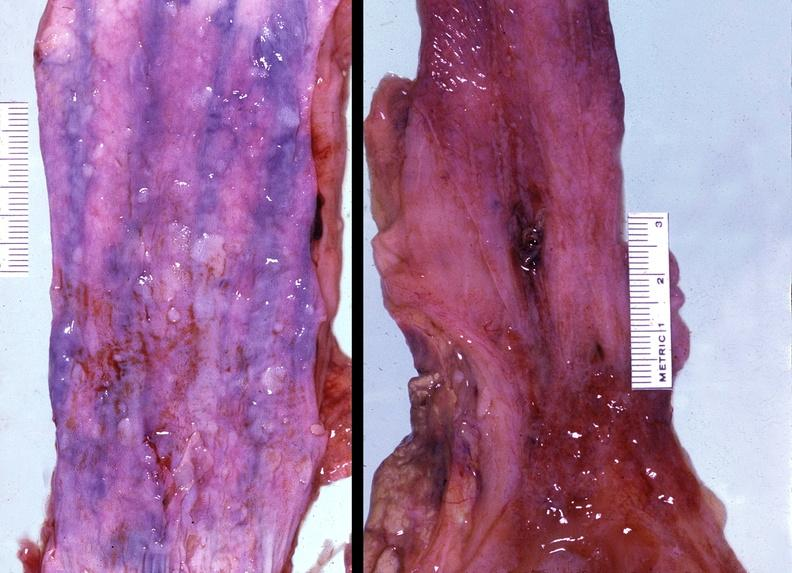what is present?
Answer the question using a single word or phrase. Gastrointestinal 